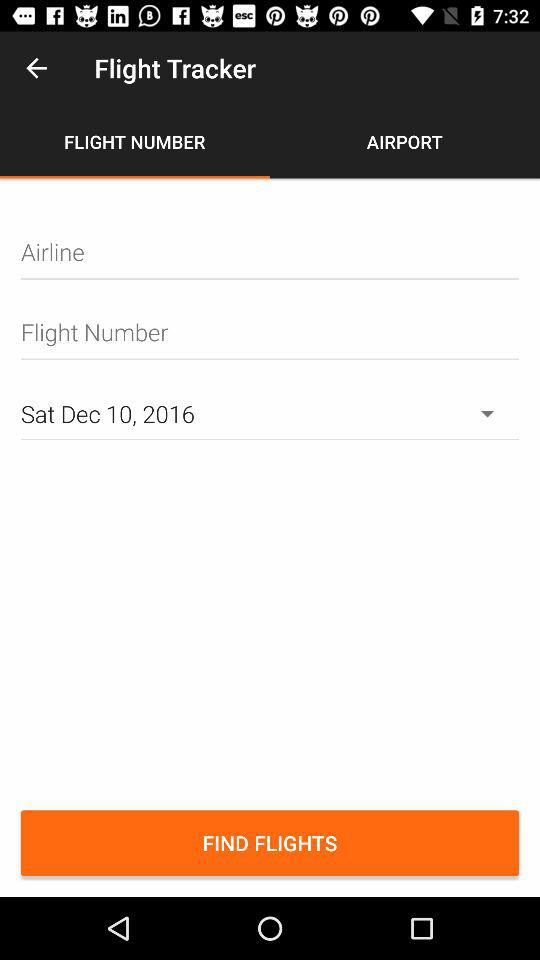What is the name of the application? The application name is "Flight Tracker". 